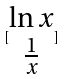Convert formula to latex. <formula><loc_0><loc_0><loc_500><loc_500>[ \begin{matrix} \ln x \\ \frac { 1 } { x } \end{matrix} ]</formula> 